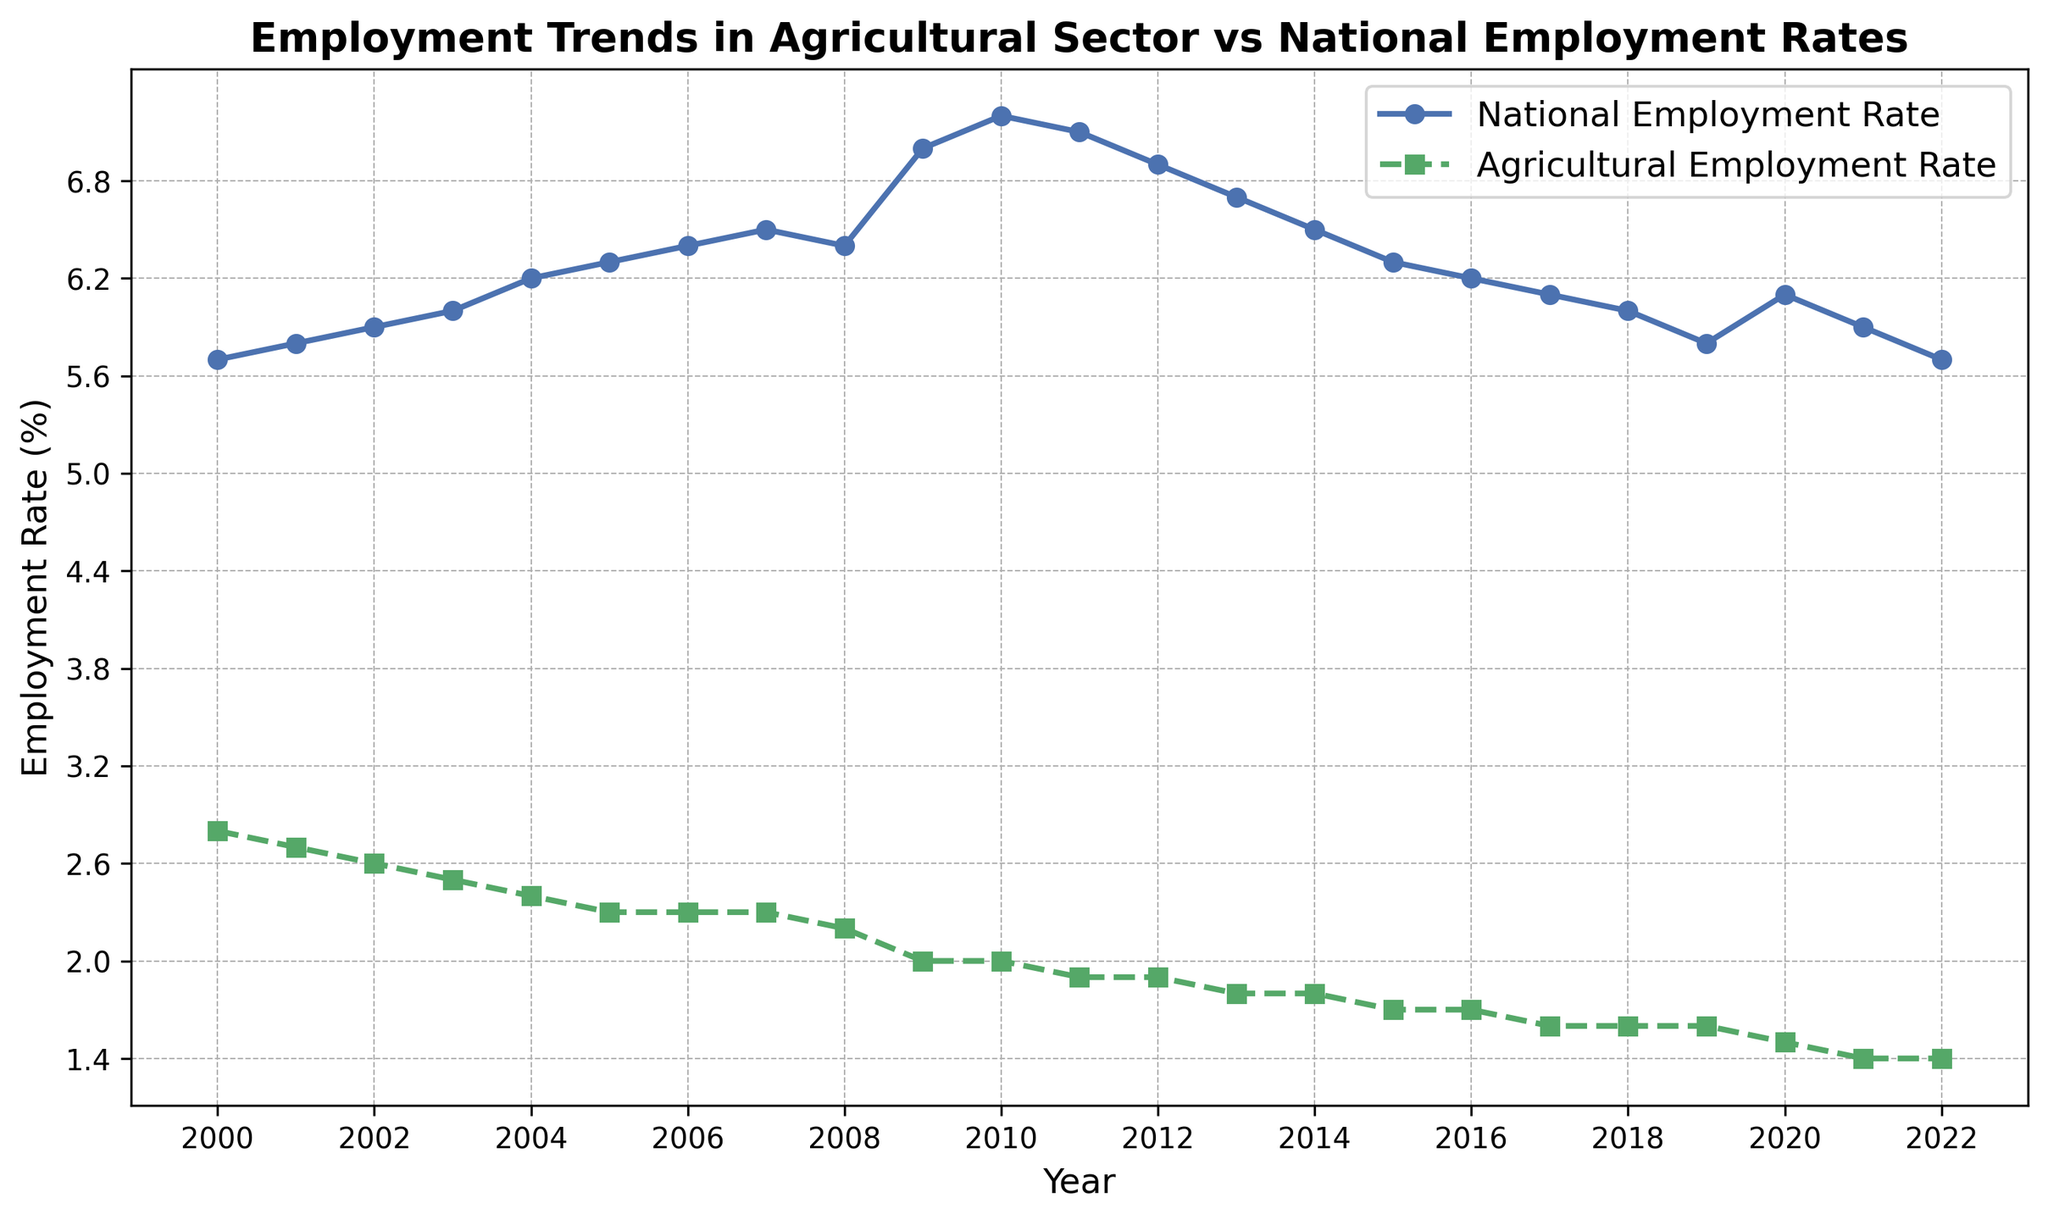What is the difference between the National Employment Rate and the Agricultural Employment Rate in the year 2000? To find the difference, subtract the Agricultural Employment Rate (2.8) from the National Employment Rate (5.7). So, 5.7 - 2.8 = 2.9
Answer: 2.9 In which year did the National Employment Rate peak? By analyzing the plot, it is visible that the peak in the National Employment Rate occurs in 2010, where the rate is the highest at 7.2%.
Answer: 2010 How did the Agricultural Employment Rate change from 2000 to 2022? The Agricultural Employment Rate in 2000 was 2.8% and declined to 1.4% in 2022. The rate decreased by 2.8 - 1.4 = 1.4 percentage points over these years.
Answer: Decreased by 1.4 percentage points By how much did the National Employment Rate change from 2019 to 2020? The National Employment Rate in 2019 was 5.8% and in 2020 it was 6.1%. The change represents an increase of 6.1 - 5.8 = 0.3 percentage points.
Answer: Increased by 0.3 percentage points Which employment rate shows a more consistent trend, and how can you tell? The Agricultural Employment Rate shows a more consistent and steady decline, whereas the National Employment Rate has more variability and fluctuations. This is perceptible by observing the smoother descent in the Agricultural Employment Rate compared to the National Employment Rate.
Answer: Agricultural Employment Rate What was the average Agricultural Employment Rate from 2000 to 2022? Sum all the Agricultural Employment Rates from 2000 to 2022 and divide by the number of years (23). (2.8 + 2.7 + 2.6 + 2.5 + 2.4 + 2.3 + 2.3 + 2.3 + 2.2 + 2.0 + 2.0 + 1.9 + 1.9 + 1.8 + 1.8 + 1.7 + 1.7 + 1.6 + 1.6 + 1.6 + 1.5 + 1.4 + 1.4) = 42.9/23 ≈ 1.87
Answer: 1.87 In which year did the Agricultural Employment Rate drop below 2% for the first time? By analyzing the plot, the first instance where the Agricultural Employment Rate drops below 2% is in 2009.
Answer: 2009 During which years did the Agricultural Employment Rate remain stable at 2.3%? From the plot, the Agricultural Employment Rate is stable at 2.3% from 2005 through 2007.
Answer: 2005-2007 Is there any year where both the National and Agricultural Employment Rates increased compared to the previous year? Examining the data, in 2020, both the National Employment Rate increased from 5.8% to 6.1%, and the Agricultural Employment Rate decreased from 1.6% to 1.5%. Thus, there's no year where both rates increased.
Answer: No Which rate had the steepest drop over a single year and when did it occur? The steepest drop in the Agricultural Employment Rate occurs between 2008 and 2009, falling from 2.2% to 2.0%, a difference of 0.2 percentage points. For the National Employment Rate, the steepest drop occurs between 2010 and 2011, from 7.2% to 7.1%, a difference of 0.1 percentage points. Hence, the Agricultural Employment Rate saw a steeper drop.
Answer: Agricultural Employment Rate in 2008-2009 